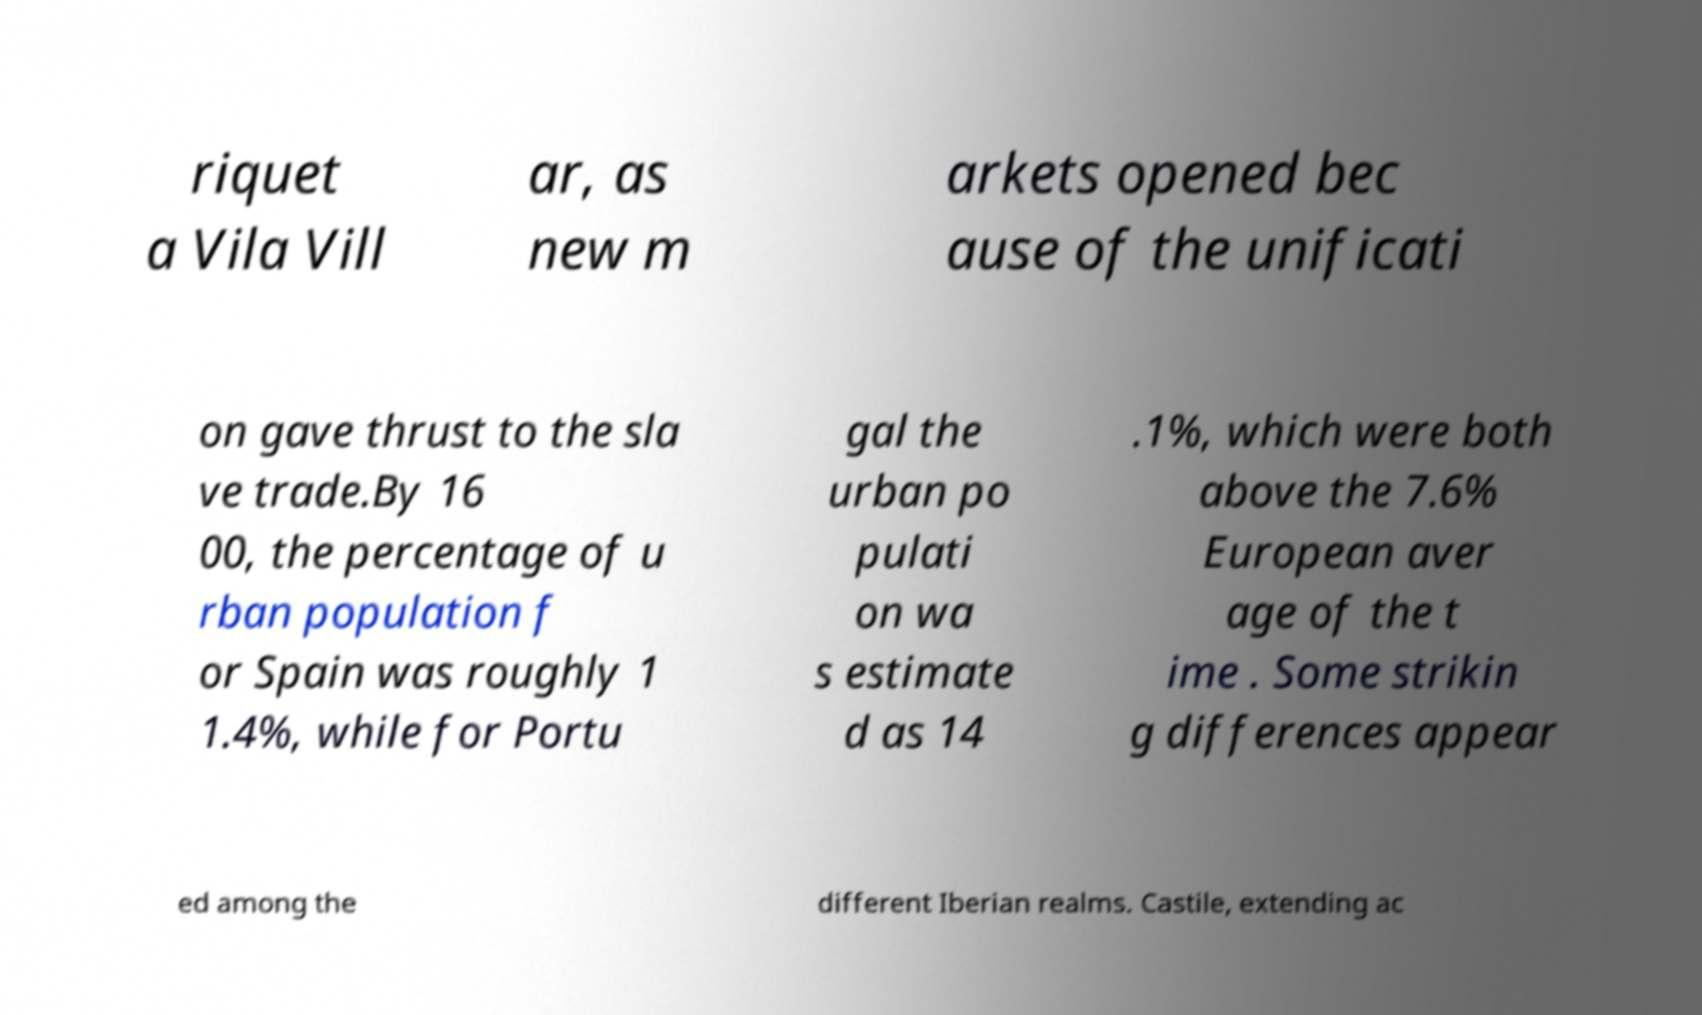Could you extract and type out the text from this image? riquet a Vila Vill ar, as new m arkets opened bec ause of the unificati on gave thrust to the sla ve trade.By 16 00, the percentage of u rban population f or Spain was roughly 1 1.4%, while for Portu gal the urban po pulati on wa s estimate d as 14 .1%, which were both above the 7.6% European aver age of the t ime . Some strikin g differences appear ed among the different Iberian realms. Castile, extending ac 